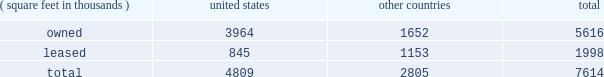Item 2 : properties information concerning applied 2019s properties is set forth below: .
Because of the interrelation of applied 2019s operations , properties within a country may be shared by the segments operating within that country .
The company 2019s headquarters offices are in santa clara , california .
Products in semiconductor systems are manufactured in santa clara , california ; austin , texas ; gloucester , massachusetts ; kalispell , montana ; rehovot , israel ; and singapore .
Remanufactured equipment products in the applied global services segment are produced primarily in austin , texas .
Products in the display and adjacent markets segment are manufactured in alzenau , germany ; and tainan , taiwan .
Other products are manufactured in treviso , italy .
Applied also owns and leases offices , plants and warehouse locations in many locations throughout the world , including in europe , japan , north america ( principally the united states ) , israel , china , india , korea , southeast asia and taiwan .
These facilities are principally used for manufacturing ; research , development and engineering ; and marketing , sales and customer support .
Applied also owns a total of approximately 269 acres of buildable land in montana , texas , california , israel and italy that could accommodate additional building space .
Applied considers the properties that it owns or leases as adequate to meet its current and future requirements .
Applied regularly assesses the size , capability and location of its global infrastructure and periodically makes adjustments based on these assessments. .
What portion of the company's property is located in united states? 
Computations: (5616 / 7614)
Answer: 0.73759. 